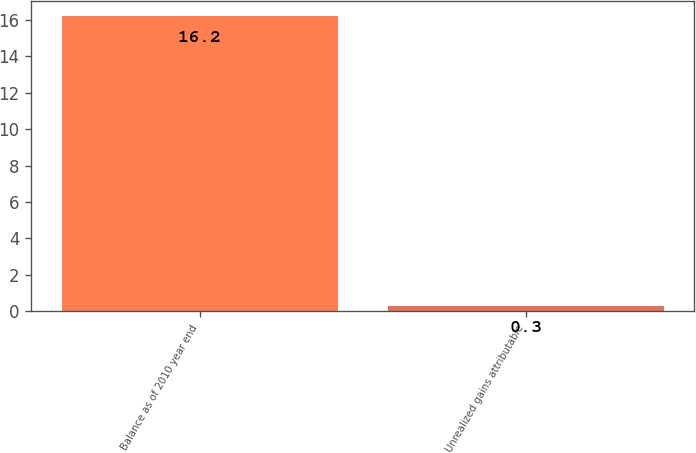Convert chart to OTSL. <chart><loc_0><loc_0><loc_500><loc_500><bar_chart><fcel>Balance as of 2010 year end<fcel>Unrealized gains attributable<nl><fcel>16.2<fcel>0.3<nl></chart> 